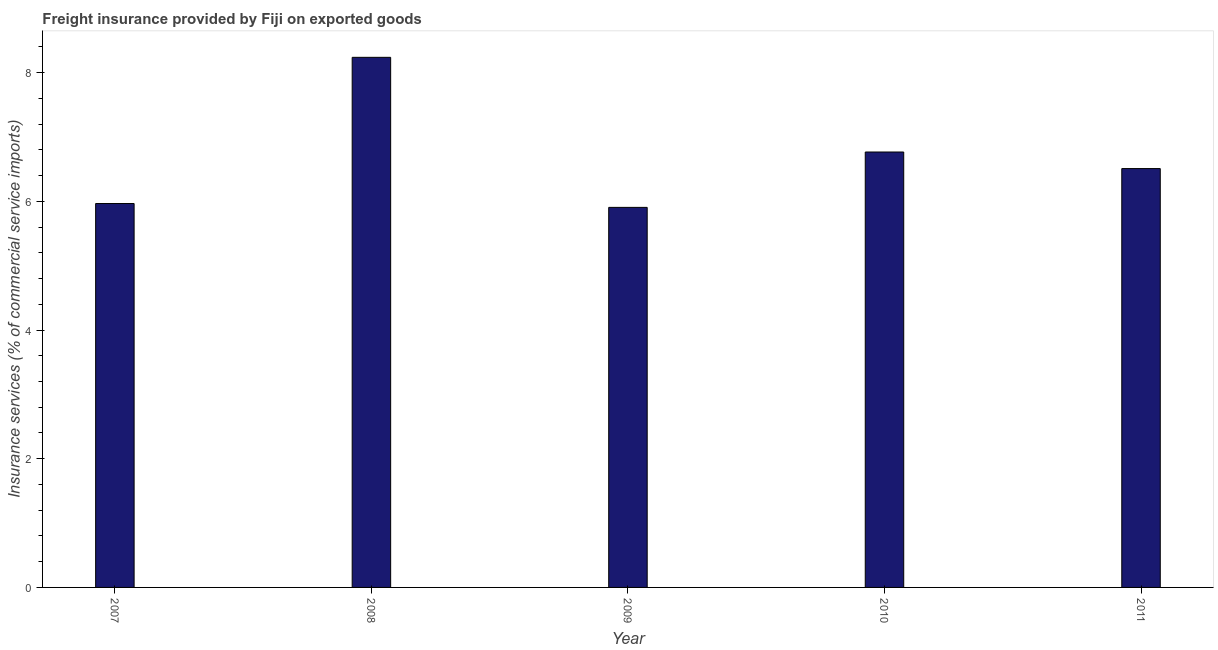Does the graph contain any zero values?
Ensure brevity in your answer.  No. Does the graph contain grids?
Ensure brevity in your answer.  No. What is the title of the graph?
Ensure brevity in your answer.  Freight insurance provided by Fiji on exported goods . What is the label or title of the Y-axis?
Offer a terse response. Insurance services (% of commercial service imports). What is the freight insurance in 2011?
Provide a short and direct response. 6.51. Across all years, what is the maximum freight insurance?
Your answer should be compact. 8.24. Across all years, what is the minimum freight insurance?
Make the answer very short. 5.91. In which year was the freight insurance minimum?
Give a very brief answer. 2009. What is the sum of the freight insurance?
Offer a terse response. 33.38. What is the difference between the freight insurance in 2008 and 2011?
Offer a very short reply. 1.73. What is the average freight insurance per year?
Make the answer very short. 6.68. What is the median freight insurance?
Make the answer very short. 6.51. In how many years, is the freight insurance greater than 8 %?
Your answer should be compact. 1. Do a majority of the years between 2011 and 2007 (inclusive) have freight insurance greater than 4 %?
Provide a succinct answer. Yes. What is the ratio of the freight insurance in 2007 to that in 2010?
Your response must be concise. 0.88. What is the difference between the highest and the second highest freight insurance?
Ensure brevity in your answer.  1.47. Is the sum of the freight insurance in 2007 and 2008 greater than the maximum freight insurance across all years?
Offer a very short reply. Yes. What is the difference between the highest and the lowest freight insurance?
Provide a succinct answer. 2.33. In how many years, is the freight insurance greater than the average freight insurance taken over all years?
Give a very brief answer. 2. Are all the bars in the graph horizontal?
Provide a short and direct response. No. How many years are there in the graph?
Your answer should be very brief. 5. What is the Insurance services (% of commercial service imports) in 2007?
Offer a very short reply. 5.97. What is the Insurance services (% of commercial service imports) of 2008?
Keep it short and to the point. 8.24. What is the Insurance services (% of commercial service imports) of 2009?
Offer a very short reply. 5.91. What is the Insurance services (% of commercial service imports) in 2010?
Your response must be concise. 6.77. What is the Insurance services (% of commercial service imports) in 2011?
Your answer should be very brief. 6.51. What is the difference between the Insurance services (% of commercial service imports) in 2007 and 2008?
Your response must be concise. -2.27. What is the difference between the Insurance services (% of commercial service imports) in 2007 and 2009?
Provide a short and direct response. 0.06. What is the difference between the Insurance services (% of commercial service imports) in 2007 and 2010?
Provide a short and direct response. -0.8. What is the difference between the Insurance services (% of commercial service imports) in 2007 and 2011?
Provide a succinct answer. -0.54. What is the difference between the Insurance services (% of commercial service imports) in 2008 and 2009?
Ensure brevity in your answer.  2.33. What is the difference between the Insurance services (% of commercial service imports) in 2008 and 2010?
Make the answer very short. 1.47. What is the difference between the Insurance services (% of commercial service imports) in 2008 and 2011?
Ensure brevity in your answer.  1.73. What is the difference between the Insurance services (% of commercial service imports) in 2009 and 2010?
Make the answer very short. -0.86. What is the difference between the Insurance services (% of commercial service imports) in 2009 and 2011?
Provide a short and direct response. -0.6. What is the difference between the Insurance services (% of commercial service imports) in 2010 and 2011?
Your answer should be compact. 0.26. What is the ratio of the Insurance services (% of commercial service imports) in 2007 to that in 2008?
Your answer should be compact. 0.72. What is the ratio of the Insurance services (% of commercial service imports) in 2007 to that in 2010?
Provide a short and direct response. 0.88. What is the ratio of the Insurance services (% of commercial service imports) in 2007 to that in 2011?
Give a very brief answer. 0.92. What is the ratio of the Insurance services (% of commercial service imports) in 2008 to that in 2009?
Give a very brief answer. 1.4. What is the ratio of the Insurance services (% of commercial service imports) in 2008 to that in 2010?
Ensure brevity in your answer.  1.22. What is the ratio of the Insurance services (% of commercial service imports) in 2008 to that in 2011?
Make the answer very short. 1.27. What is the ratio of the Insurance services (% of commercial service imports) in 2009 to that in 2010?
Offer a very short reply. 0.87. What is the ratio of the Insurance services (% of commercial service imports) in 2009 to that in 2011?
Your response must be concise. 0.91. What is the ratio of the Insurance services (% of commercial service imports) in 2010 to that in 2011?
Your answer should be very brief. 1.04. 